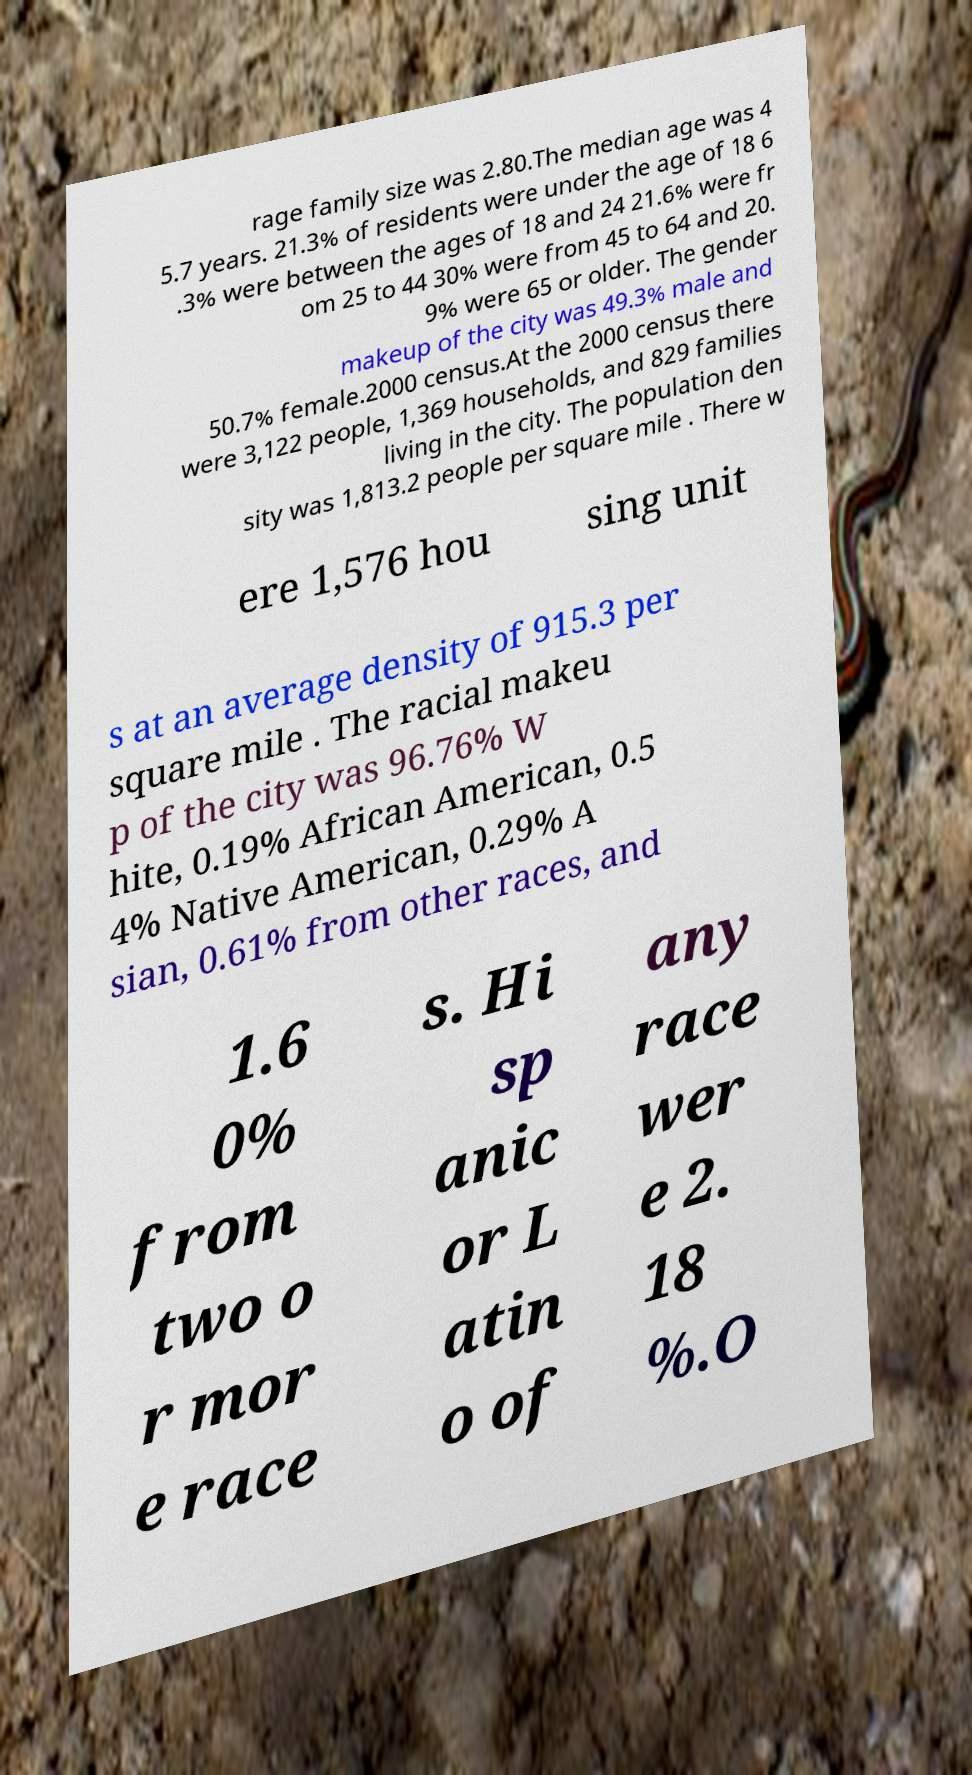Could you extract and type out the text from this image? rage family size was 2.80.The median age was 4 5.7 years. 21.3% of residents were under the age of 18 6 .3% were between the ages of 18 and 24 21.6% were fr om 25 to 44 30% were from 45 to 64 and 20. 9% were 65 or older. The gender makeup of the city was 49.3% male and 50.7% female.2000 census.At the 2000 census there were 3,122 people, 1,369 households, and 829 families living in the city. The population den sity was 1,813.2 people per square mile . There w ere 1,576 hou sing unit s at an average density of 915.3 per square mile . The racial makeu p of the city was 96.76% W hite, 0.19% African American, 0.5 4% Native American, 0.29% A sian, 0.61% from other races, and 1.6 0% from two o r mor e race s. Hi sp anic or L atin o of any race wer e 2. 18 %.O 